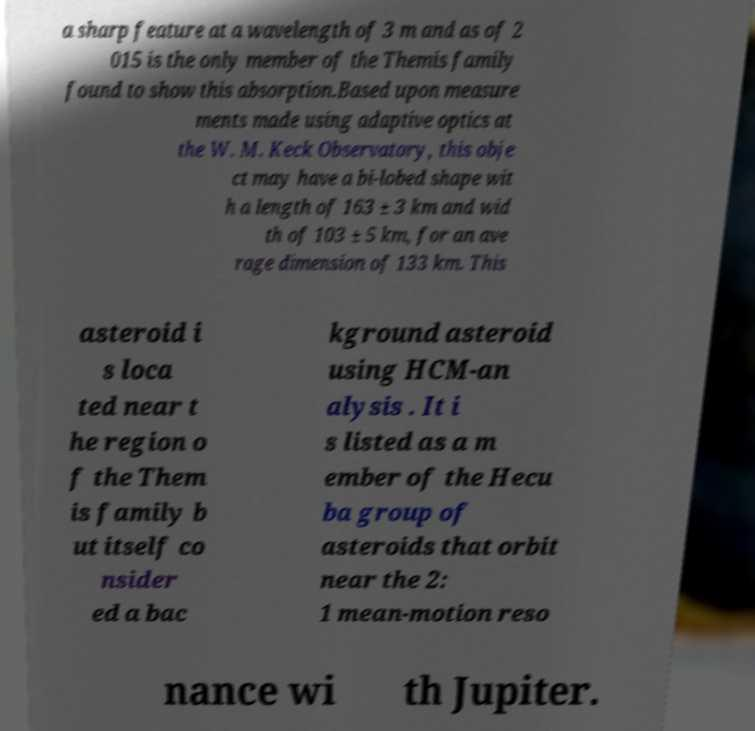Can you accurately transcribe the text from the provided image for me? a sharp feature at a wavelength of 3 m and as of 2 015 is the only member of the Themis family found to show this absorption.Based upon measure ments made using adaptive optics at the W. M. Keck Observatory, this obje ct may have a bi-lobed shape wit h a length of 163 ± 3 km and wid th of 103 ± 5 km, for an ave rage dimension of 133 km. This asteroid i s loca ted near t he region o f the Them is family b ut itself co nsider ed a bac kground asteroid using HCM-an alysis . It i s listed as a m ember of the Hecu ba group of asteroids that orbit near the 2: 1 mean-motion reso nance wi th Jupiter. 